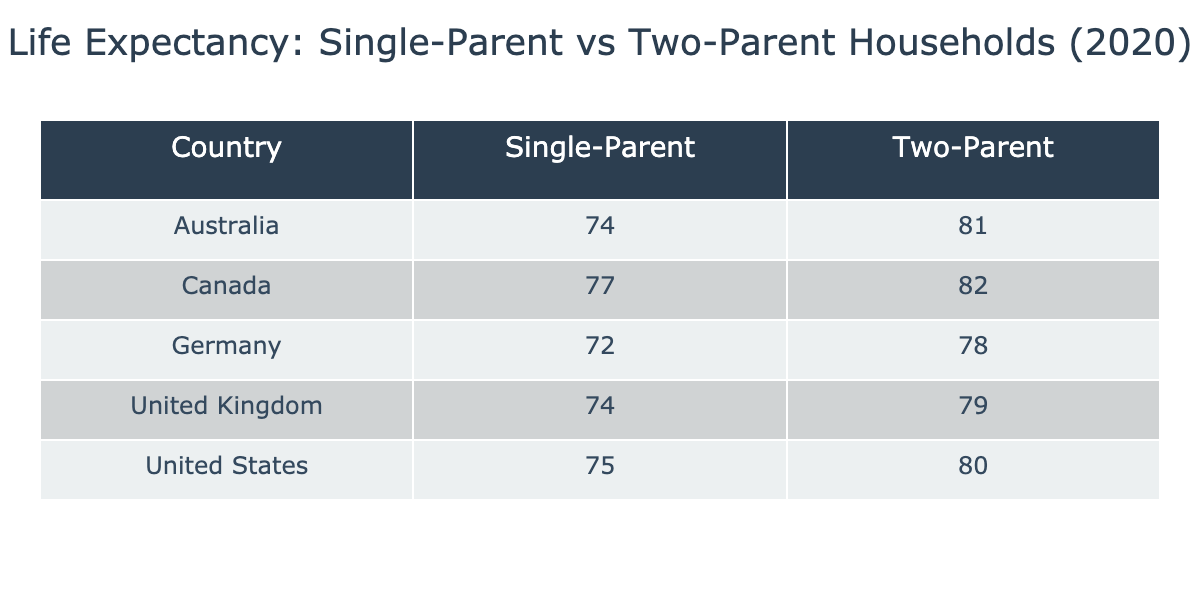What is the life expectancy for single-parent households in the United States? Looking at the table, under the "Single-Parent" column for the "United States," the listed life expectancy age is 75.
Answer: 75 What is the life expectancy for two-parent households in Canada? From the table, the life expectancy for the "Two-Parent" category in "Canada" is 82.
Answer: 82 Which household type has a higher life expectancy in Germany? In the table, the life expectancy for "Single-Parent" households in Germany is 72, while for "Two-Parent" households it's 78. The two-parent household has a higher life expectancy.
Answer: Two-Parent What is the average life expectancy for single-parent households across all countries shown? The life expectancies for single-parent households are 75, 74, 77, 72, and 74. To find the average, sum these values (75 + 74 + 77 + 72 + 74 = 372) and then divide by the number of data points (5). So, 372/5 = 74.4.
Answer: 74.4 Is it true that in the UK, single-parent households have a longer life expectancy than two-parent households? According to the table, the life expectancy for single-parent households in the UK is 74, and for two-parent households, it is 79. Since 74 is less than 79, it is not true.
Answer: No What is the difference in life expectancy between single-parent and two-parent households in Australia? From the table, the life expectancy for single-parent households in Australia is 74, and for two-parent households, it is 81. To find the difference, subtract the single-parent figure from the two-parent figure (81 - 74 = 7).
Answer: 7 In which country do single-parent households have the highest life expectancy? The highest life expectancy in the "Single-Parent" category is found in Canada, with a life expectancy of 77.
Answer: Canada What is the total life expectancy for single-parent households in all the listed countries? Referring to the life expectancies for single-parent households, we have 75, 74, 77, 72, and 74. Adding these together gives a total of (75 + 74 + 77 + 72 + 74 = 372).
Answer: 372 Are there any countries where the life expectancy for two-parent households is less than that of single-parent households? In the table, the life expectancies for two-parent households are all higher than their respective single-parent counterparts. Therefore, there are no such countries.
Answer: No 